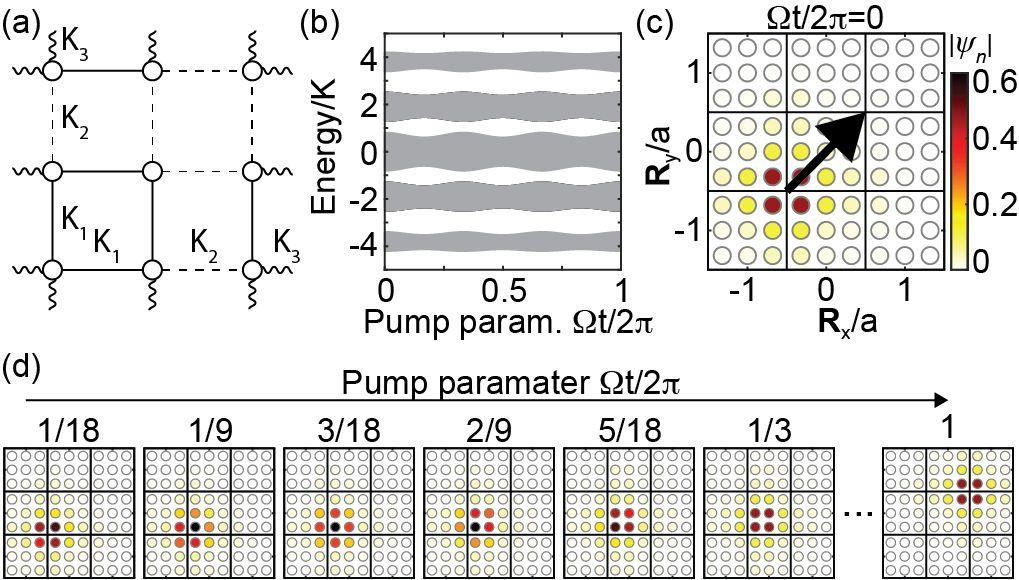How do the patterns in Subfigure (d) evolve across the pump parameters? Subfigure (d) shows a series of visual representations of certain properties as the pump parameter increases from 1/18 to 1. Each cell represents a state or condition at a specific pump parameter value, depicted by evolving colors and patterns. As the pump parameter increases, the patterns and colors change, suggesting differences in the physical or emotional states being represented. This evolution can help researchers or viewers understand how incremental changes in the pump parameters impact the system's overall behavior. What could the different colors in each state signify? The diverse colors in each state likely correspond to different magnitudes or types of the parameter being measured. For instance, varying shades from pale yellow to deep red might indicate increasing intensity or concentration of a particular element. Understanding these colors can provide deeper insight into the quantitative or qualitative changes occurring in the system with each increment in pump parameters, offering a richer understanding of the underlying processes. 